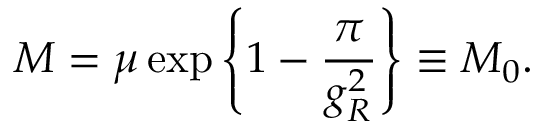Convert formula to latex. <formula><loc_0><loc_0><loc_500><loc_500>M = \mu \exp \left \{ 1 - \frac { \pi } { g _ { R } ^ { 2 } } \right \} \equiv M _ { 0 } .</formula> 